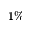Convert formula to latex. <formula><loc_0><loc_0><loc_500><loc_500>1 \%</formula> 